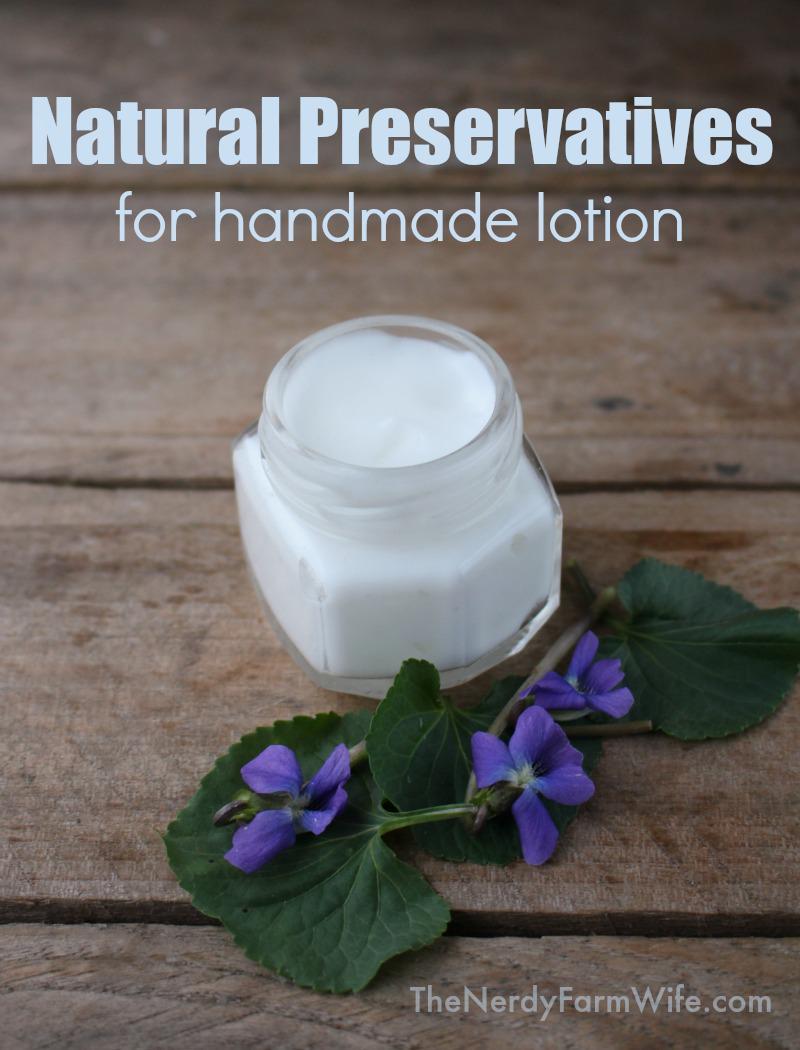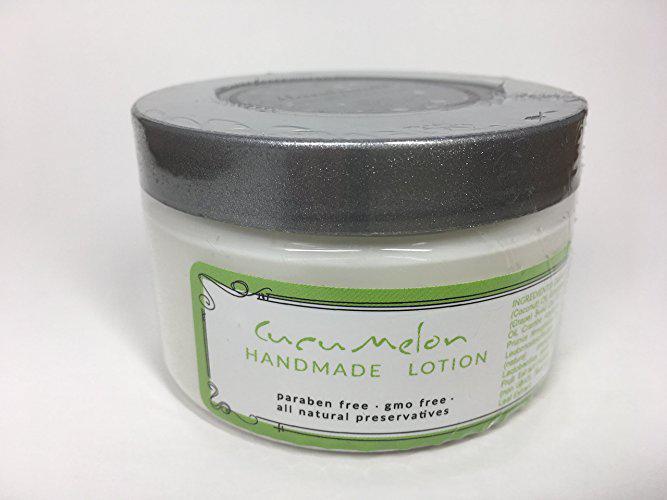The first image is the image on the left, the second image is the image on the right. Given the left and right images, does the statement "At least one container is open." hold true? Answer yes or no. Yes. The first image is the image on the left, the second image is the image on the right. For the images shown, is this caption "In at least one image there is a total of five fragrance bottle with closed white caps." true? Answer yes or no. No. 